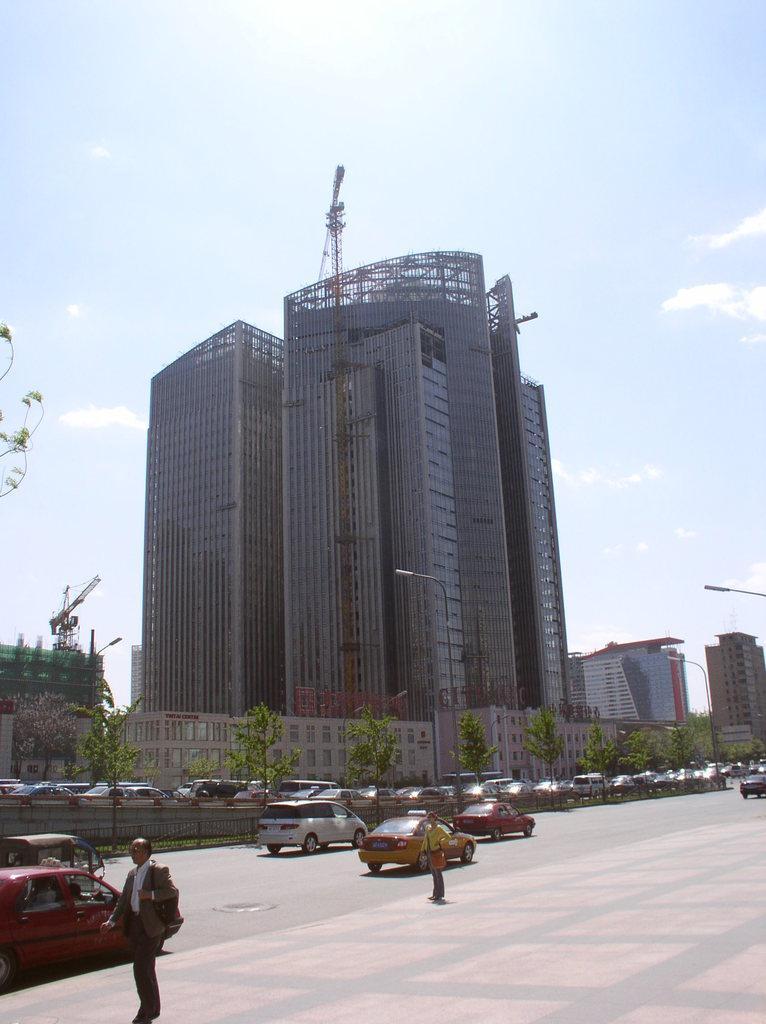Can you describe this image briefly? In this image there are buildings and there are a few cranes, in front of the building there are trees and a few vehicles are walking on the pavement. In the background there is the sky. 